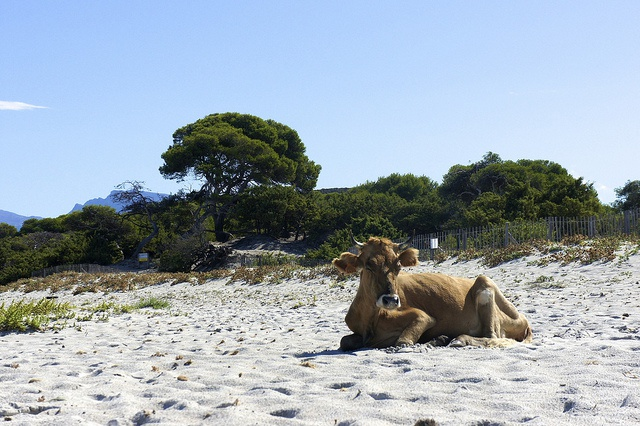Describe the objects in this image and their specific colors. I can see a cow in lightblue, black, and gray tones in this image. 